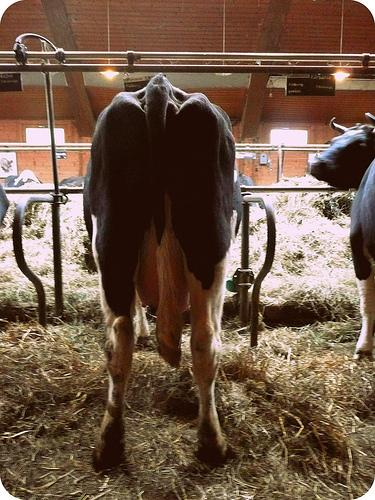List all the metal objects in the image. The metal objects include tall metal pole next to cow, metal box (electrical) on wall, metal rail, curved metal bar between cows, metal post, and curved metal poles. Count the number of cows in the image and specify their color. There are two cows in the image, one is black and white, and the other has a black body with white legs. Describe the objects that are above the cows. Above the cows, there are poles, wooden ceiling, rafters, a row of lights that are on, and a long metal beam. What type of sentiment or mood does the image evoke? The image evokes a peaceful, rustic, and rural sentiment, as it shows cows in a barn with natural elements like hay. What type of object is providing the bright yellow light in the air? A row of lights, which are turned on, provide the bright yellow light suspended in the air. What are the distinct features of the cow looking towards the camera? The cow looking towards the camera is black and white, has gray curved horns, and a black and white tail. Identify the type of flooring in the cow barn. The cow barn has hay or straw covering the ground as flooring. Provide an overall description of the scene in the image. The scene shows a cow barn with two cows, hay on the ground, and various features like metal poles, windows, and an electrical box on the back wall. How many windows are there in the cow barn, and what is their position? There are two windows in the cow barn - one on the left and one on the right, at the back wall. Mention the objects found at the back wall of the cow barn. There is a bright window, a metal box that seems to be an electrical box, and a black sign with white writing on the back wall. 